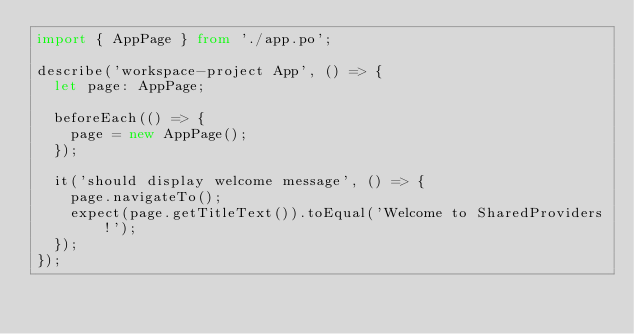Convert code to text. <code><loc_0><loc_0><loc_500><loc_500><_TypeScript_>import { AppPage } from './app.po';

describe('workspace-project App', () => {
  let page: AppPage;

  beforeEach(() => {
    page = new AppPage();
  });

  it('should display welcome message', () => {
    page.navigateTo();
    expect(page.getTitleText()).toEqual('Welcome to SharedProviders!');
  });
});
</code> 